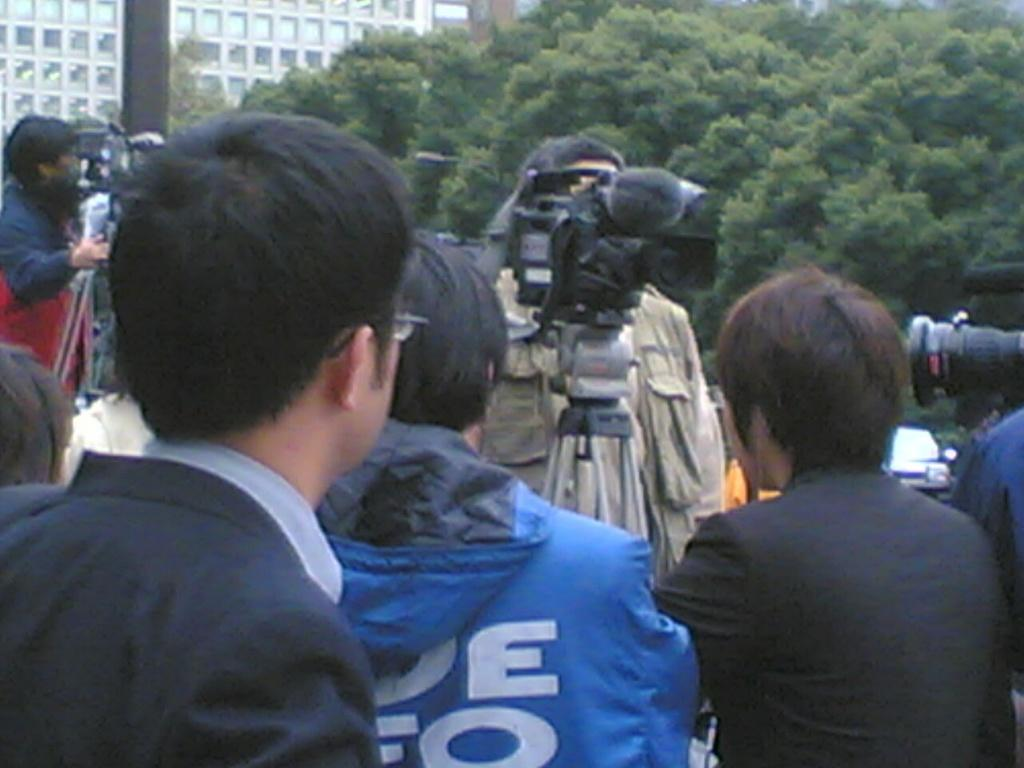Who is present in the image? A: There are people in the image. What are some of the people doing in the image? Some of the people are holding cameras. What can be seen in the background of the image? There are trees and a building in the background of the image. How many clocks can be seen hanging from the trees in the image? There are no clocks hanging from the trees in the image. Can you tell me the color of the donkey in the image? There is no donkey present in the image. 